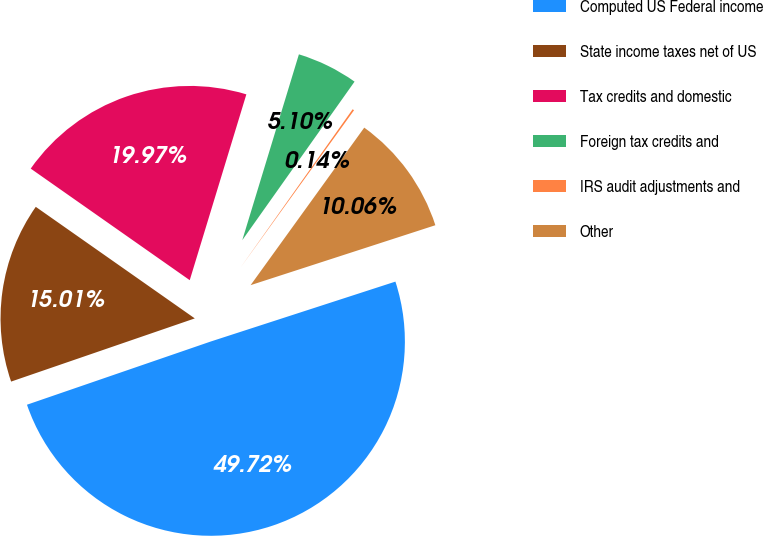Convert chart to OTSL. <chart><loc_0><loc_0><loc_500><loc_500><pie_chart><fcel>Computed US Federal income<fcel>State income taxes net of US<fcel>Tax credits and domestic<fcel>Foreign tax credits and<fcel>IRS audit adjustments and<fcel>Other<nl><fcel>49.72%<fcel>15.01%<fcel>19.97%<fcel>5.1%<fcel>0.14%<fcel>10.06%<nl></chart> 